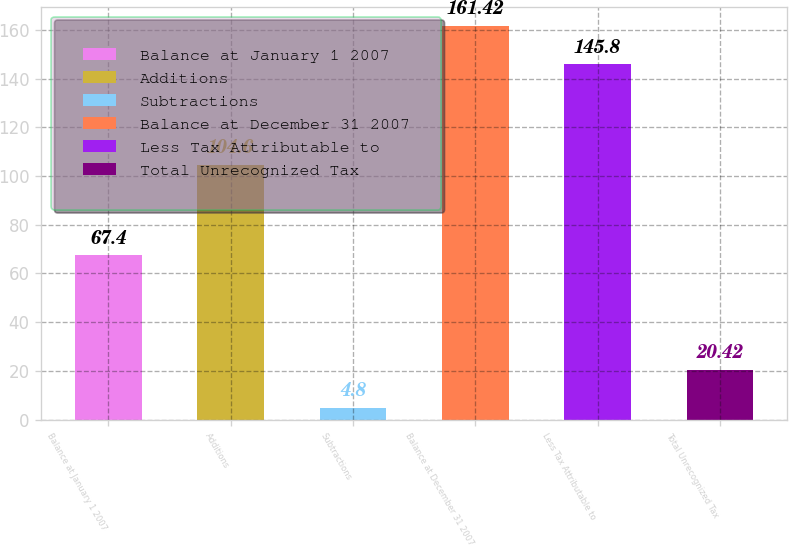<chart> <loc_0><loc_0><loc_500><loc_500><bar_chart><fcel>Balance at January 1 2007<fcel>Additions<fcel>Subtractions<fcel>Balance at December 31 2007<fcel>Less Tax Attributable to<fcel>Total Unrecognized Tax<nl><fcel>67.4<fcel>104.6<fcel>4.8<fcel>161.42<fcel>145.8<fcel>20.42<nl></chart> 